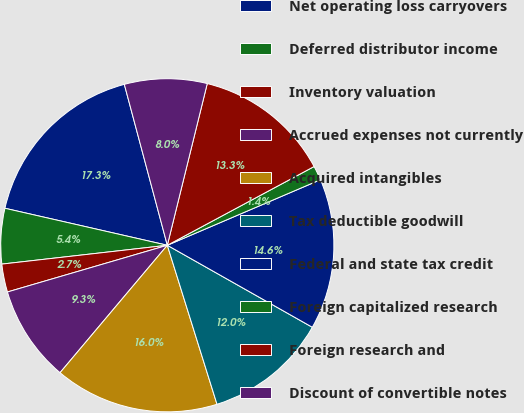Convert chart. <chart><loc_0><loc_0><loc_500><loc_500><pie_chart><fcel>Net operating loss carryovers<fcel>Deferred distributor income<fcel>Inventory valuation<fcel>Accrued expenses not currently<fcel>Acquired intangibles<fcel>Tax deductible goodwill<fcel>Federal and state tax credit<fcel>Foreign capitalized research<fcel>Foreign research and<fcel>Discount of convertible notes<nl><fcel>17.28%<fcel>5.37%<fcel>2.72%<fcel>9.34%<fcel>15.96%<fcel>11.99%<fcel>14.63%<fcel>1.4%<fcel>13.31%<fcel>8.01%<nl></chart> 